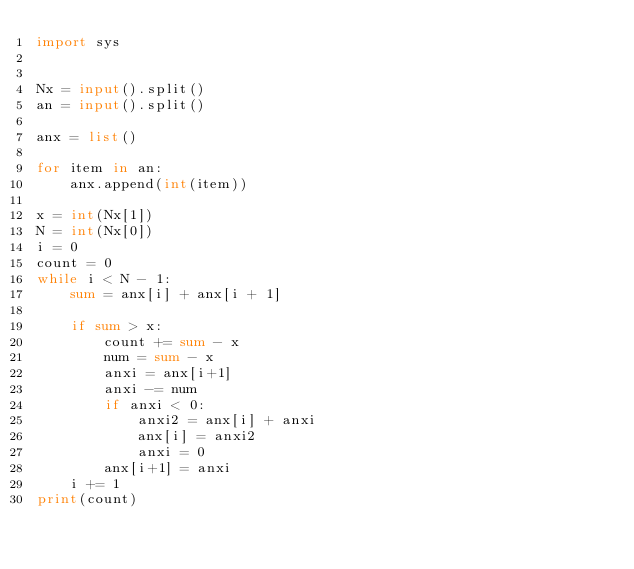Convert code to text. <code><loc_0><loc_0><loc_500><loc_500><_Python_>import sys


Nx = input().split()
an = input().split()

anx = list()

for item in an:
    anx.append(int(item))

x = int(Nx[1])
N = int(Nx[0])
i = 0
count = 0
while i < N - 1:
    sum = anx[i] + anx[i + 1]
    
    if sum > x:
        count += sum - x
        num = sum - x
        anxi = anx[i+1]
        anxi -= num
        if anxi < 0:
            anxi2 = anx[i] + anxi
            anx[i] = anxi2
            anxi = 0
        anx[i+1] = anxi
    i += 1
print(count)
</code> 